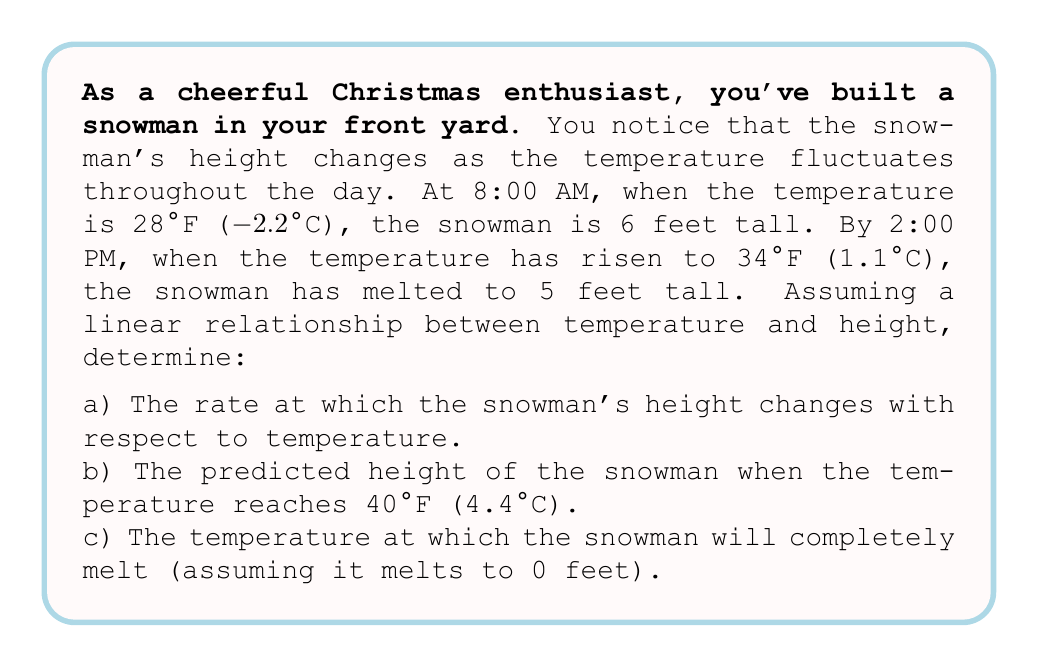Could you help me with this problem? Let's approach this problem step-by-step:

1) First, let's define our variables:
   $h$ = height of the snowman (in feet)
   $T$ = temperature (in °F)

2) We're told that the relationship between height and temperature is linear, so we can use the slope formula:

   $$m = \frac{\Delta h}{\Delta T} = \frac{h_2 - h_1}{T_2 - T_1}$$

3) We have two points:
   $(T_1, h_1) = (28, 6)$ and $(T_2, h_2) = (34, 5)$

4) Let's calculate the rate of change (slope):

   $$m = \frac{5 - 6}{34 - 28} = \frac{-1}{6} = -\frac{1}{6} \text{ ft/°F}$$

5) This answers part (a). The negative value indicates that as temperature increases, height decreases.

6) For part (b), we can use the point-slope form of a line:
   $h - h_1 = m(T - T_1)$

   Plugging in our known point $(28, 6)$ and $m = -\frac{1}{6}$:

   $$h - 6 = -\frac{1}{6}(T - 28)$$

7) To find the height at 40°F, we substitute $T = 40$:

   $$h - 6 = -\frac{1}{6}(40 - 28)$$
   $$h - 6 = -\frac{1}{6}(12) = -2$$
   $$h = 4 \text{ feet}$$

8) For part (c), we want to find $T$ when $h = 0$. Using our equation from step 6:

   $$0 - 6 = -\frac{1}{6}(T - 28)$$
   $$-6 = -\frac{1}{6}(T - 28)$$
   $$36 = T - 28$$
   $$T = 64°F$$
Answer: a) The rate of change is $-\frac{1}{6}$ feet per °F.
b) At 40°F, the snowman's predicted height is 4 feet.
c) The snowman will completely melt at 64°F. 